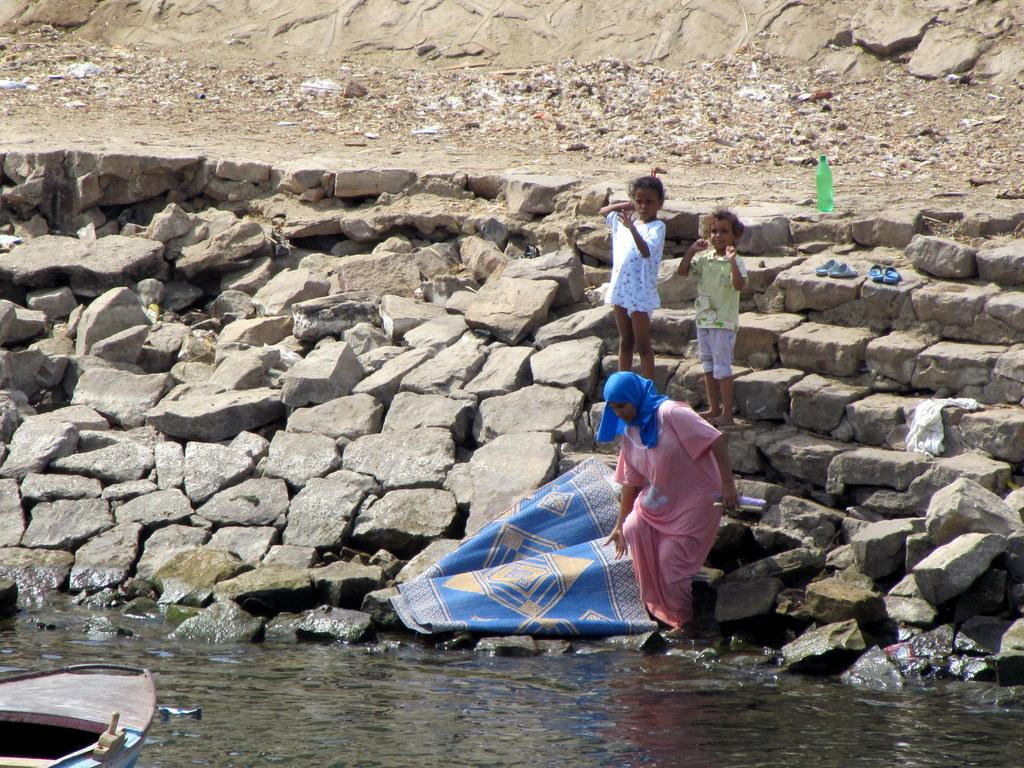What type of objects can be seen in the image? There are stones in the image. Can you describe the people in the image? There are people in the image. What is the bottle used for in the image? The bottle is in the image, but its purpose is not specified. What type of footwear is present in the image? There are slippers in the image. What is the mat used for in the image? The mat is in the image, but its purpose is not specified. What type of vehicle is in the image? There is a boat in the image. What natural element is visible in the image? There is water visible in the image. How many bricks are being used to build the boat in the image? There are no bricks present in the image, and the boat is not being built. What is the value of the stones in the image? The value of the stones is not specified in the image. How many chickens are visible in the image? There are no chickens present in the image. 